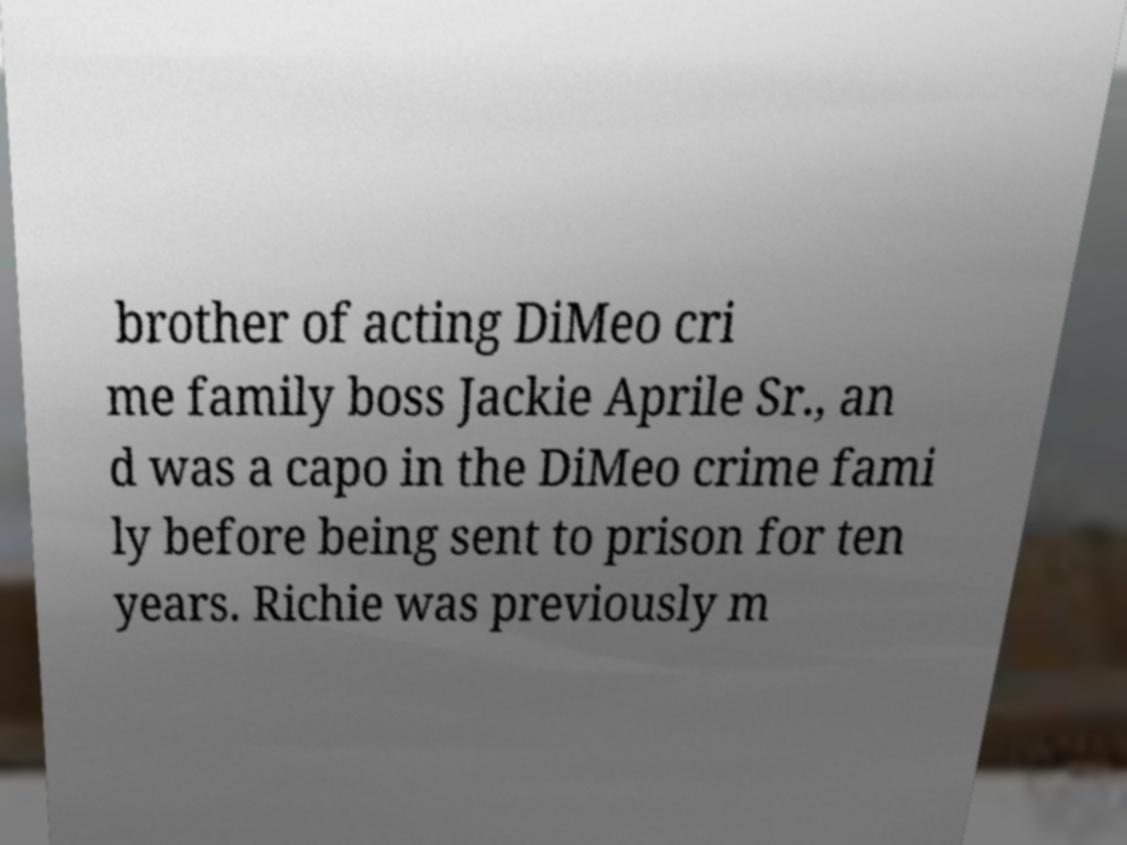What messages or text are displayed in this image? I need them in a readable, typed format. brother of acting DiMeo cri me family boss Jackie Aprile Sr., an d was a capo in the DiMeo crime fami ly before being sent to prison for ten years. Richie was previously m 